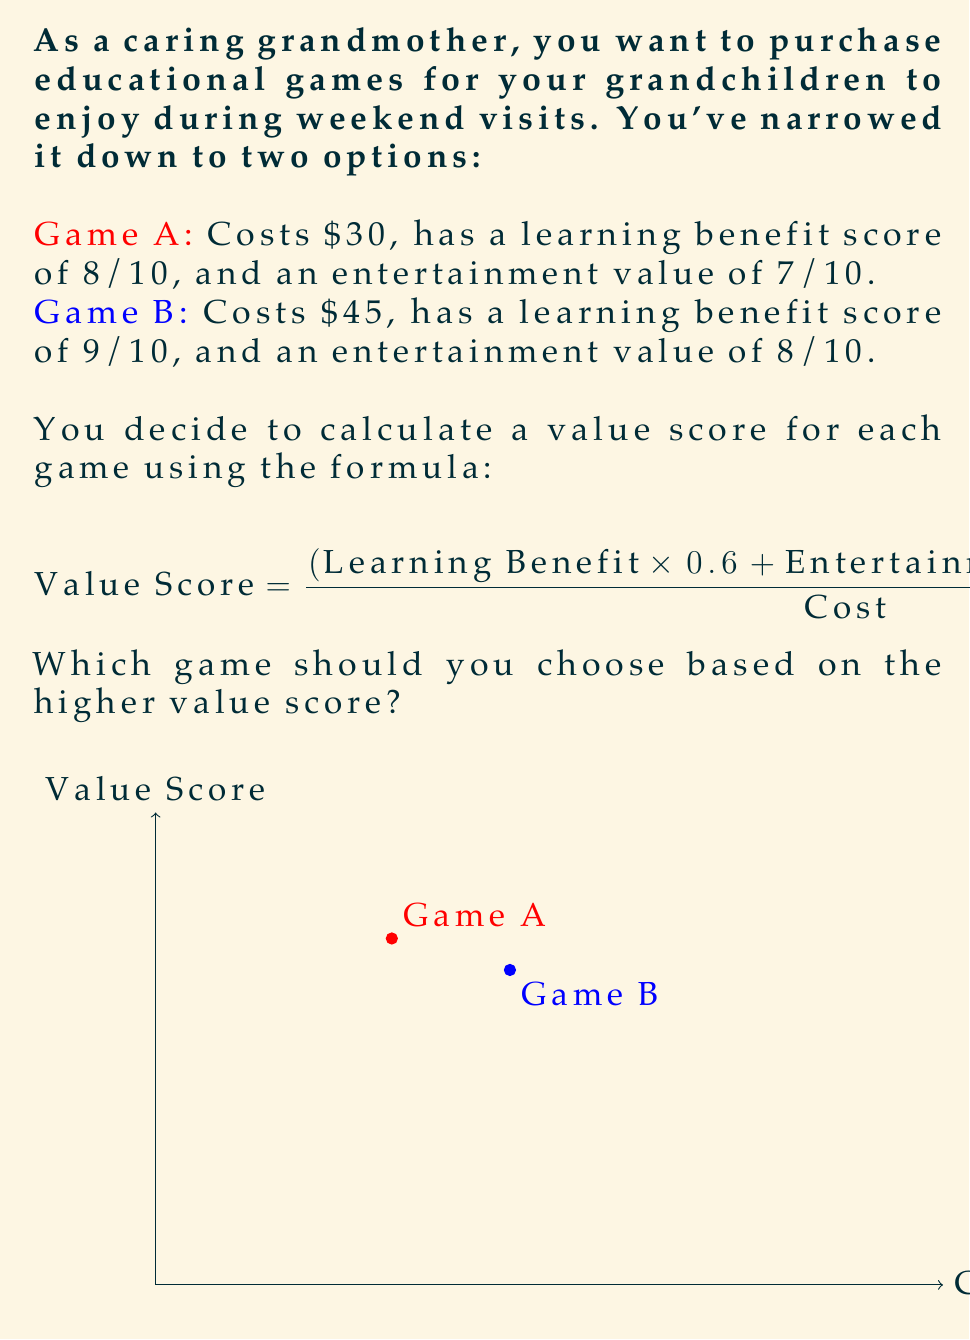What is the answer to this math problem? Let's calculate the value score for each game:

1. For Game A:
   Learning Benefit = 8, Entertainment Value = 7, Cost = $30
   $$ \text{Value Score}_A = \frac{(8 \times 0.6 + 7 \times 0.4) \times 10}{30} $$
   $$ = \frac{(4.8 + 2.8) \times 10}{30} = \frac{7.6 \times 10}{30} = \frac{76}{30} = 2.53 $$

2. For Game B:
   Learning Benefit = 9, Entertainment Value = 8, Cost = $45
   $$ \text{Value Score}_B = \frac{(9 \times 0.6 + 8 \times 0.4) \times 10}{45} $$
   $$ = \frac{(5.4 + 3.2) \times 10}{45} = \frac{8.6 \times 10}{45} = \frac{86}{45} = 1.91 $$

3. Compare the value scores:
   Game A: 2.53
   Game B: 1.91

Game A has a higher value score, despite its lower learning benefit and entertainment value, due to its lower cost.
Answer: Game A 